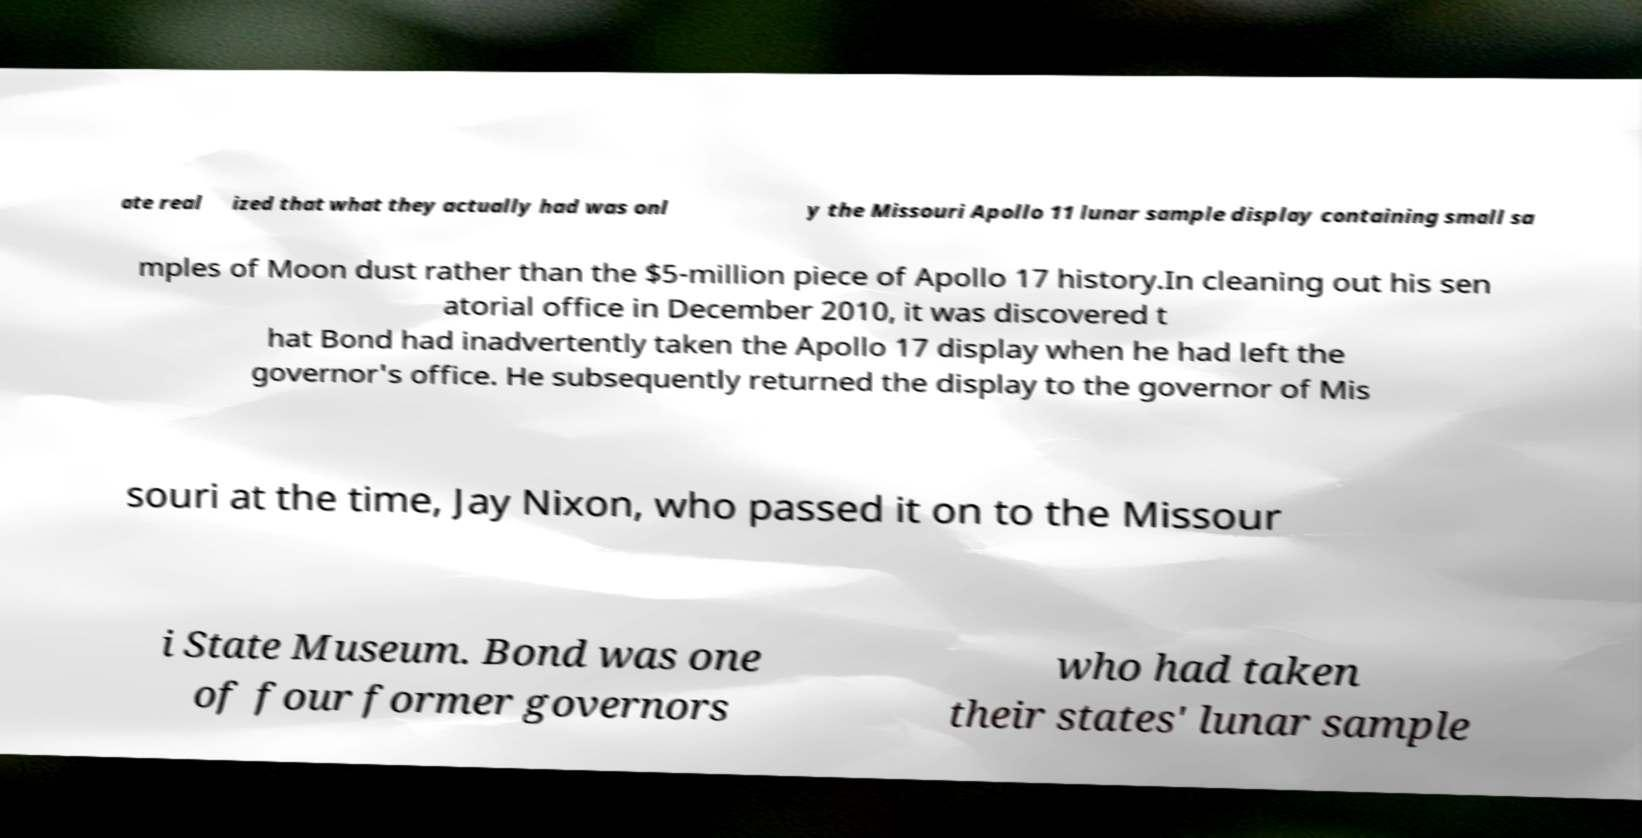Could you extract and type out the text from this image? ate real ized that what they actually had was onl y the Missouri Apollo 11 lunar sample display containing small sa mples of Moon dust rather than the $5-million piece of Apollo 17 history.In cleaning out his sen atorial office in December 2010, it was discovered t hat Bond had inadvertently taken the Apollo 17 display when he had left the governor's office. He subsequently returned the display to the governor of Mis souri at the time, Jay Nixon, who passed it on to the Missour i State Museum. Bond was one of four former governors who had taken their states' lunar sample 